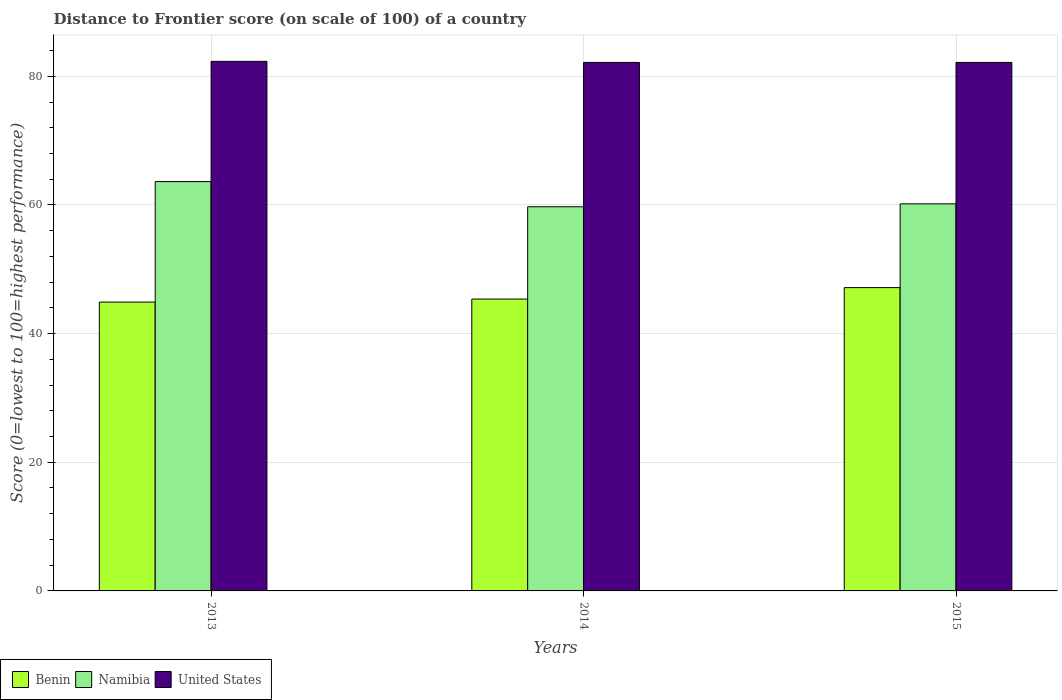How many different coloured bars are there?
Ensure brevity in your answer.  3. How many bars are there on the 3rd tick from the left?
Your response must be concise. 3. How many bars are there on the 2nd tick from the right?
Offer a terse response. 3. In how many cases, is the number of bars for a given year not equal to the number of legend labels?
Offer a very short reply. 0. What is the distance to frontier score of in United States in 2014?
Your response must be concise. 82.15. Across all years, what is the maximum distance to frontier score of in Benin?
Your response must be concise. 47.15. Across all years, what is the minimum distance to frontier score of in Namibia?
Provide a succinct answer. 59.72. What is the total distance to frontier score of in Benin in the graph?
Offer a terse response. 137.42. What is the difference between the distance to frontier score of in United States in 2014 and that in 2015?
Provide a short and direct response. 0. What is the difference between the distance to frontier score of in Namibia in 2015 and the distance to frontier score of in Benin in 2013?
Make the answer very short. 15.27. What is the average distance to frontier score of in Benin per year?
Offer a very short reply. 45.81. In the year 2013, what is the difference between the distance to frontier score of in United States and distance to frontier score of in Benin?
Offer a very short reply. 37.42. In how many years, is the distance to frontier score of in United States greater than 56?
Provide a succinct answer. 3. What is the ratio of the distance to frontier score of in Benin in 2013 to that in 2014?
Offer a very short reply. 0.99. Is the distance to frontier score of in Benin in 2013 less than that in 2014?
Offer a terse response. Yes. Is the difference between the distance to frontier score of in United States in 2013 and 2015 greater than the difference between the distance to frontier score of in Benin in 2013 and 2015?
Make the answer very short. Yes. What is the difference between the highest and the second highest distance to frontier score of in Namibia?
Offer a terse response. 3.46. What is the difference between the highest and the lowest distance to frontier score of in United States?
Keep it short and to the point. 0.17. In how many years, is the distance to frontier score of in Benin greater than the average distance to frontier score of in Benin taken over all years?
Provide a short and direct response. 1. What does the 1st bar from the left in 2014 represents?
Offer a terse response. Benin. What does the 3rd bar from the right in 2013 represents?
Ensure brevity in your answer.  Benin. Is it the case that in every year, the sum of the distance to frontier score of in Benin and distance to frontier score of in United States is greater than the distance to frontier score of in Namibia?
Ensure brevity in your answer.  Yes. What is the difference between two consecutive major ticks on the Y-axis?
Provide a short and direct response. 20. Are the values on the major ticks of Y-axis written in scientific E-notation?
Keep it short and to the point. No. Does the graph contain grids?
Give a very brief answer. Yes. Where does the legend appear in the graph?
Offer a very short reply. Bottom left. How are the legend labels stacked?
Keep it short and to the point. Horizontal. What is the title of the graph?
Give a very brief answer. Distance to Frontier score (on scale of 100) of a country. Does "Papua New Guinea" appear as one of the legend labels in the graph?
Offer a terse response. No. What is the label or title of the X-axis?
Provide a succinct answer. Years. What is the label or title of the Y-axis?
Keep it short and to the point. Score (0=lowest to 100=highest performance). What is the Score (0=lowest to 100=highest performance) in Benin in 2013?
Your answer should be compact. 44.9. What is the Score (0=lowest to 100=highest performance) in Namibia in 2013?
Your response must be concise. 63.63. What is the Score (0=lowest to 100=highest performance) of United States in 2013?
Your response must be concise. 82.32. What is the Score (0=lowest to 100=highest performance) of Benin in 2014?
Offer a terse response. 45.37. What is the Score (0=lowest to 100=highest performance) of Namibia in 2014?
Keep it short and to the point. 59.72. What is the Score (0=lowest to 100=highest performance) in United States in 2014?
Your answer should be compact. 82.15. What is the Score (0=lowest to 100=highest performance) in Benin in 2015?
Your answer should be very brief. 47.15. What is the Score (0=lowest to 100=highest performance) of Namibia in 2015?
Offer a terse response. 60.17. What is the Score (0=lowest to 100=highest performance) in United States in 2015?
Keep it short and to the point. 82.15. Across all years, what is the maximum Score (0=lowest to 100=highest performance) in Benin?
Your answer should be compact. 47.15. Across all years, what is the maximum Score (0=lowest to 100=highest performance) of Namibia?
Give a very brief answer. 63.63. Across all years, what is the maximum Score (0=lowest to 100=highest performance) of United States?
Make the answer very short. 82.32. Across all years, what is the minimum Score (0=lowest to 100=highest performance) of Benin?
Provide a short and direct response. 44.9. Across all years, what is the minimum Score (0=lowest to 100=highest performance) of Namibia?
Offer a terse response. 59.72. Across all years, what is the minimum Score (0=lowest to 100=highest performance) of United States?
Your response must be concise. 82.15. What is the total Score (0=lowest to 100=highest performance) of Benin in the graph?
Keep it short and to the point. 137.42. What is the total Score (0=lowest to 100=highest performance) of Namibia in the graph?
Your response must be concise. 183.52. What is the total Score (0=lowest to 100=highest performance) of United States in the graph?
Ensure brevity in your answer.  246.62. What is the difference between the Score (0=lowest to 100=highest performance) in Benin in 2013 and that in 2014?
Provide a short and direct response. -0.47. What is the difference between the Score (0=lowest to 100=highest performance) in Namibia in 2013 and that in 2014?
Provide a short and direct response. 3.91. What is the difference between the Score (0=lowest to 100=highest performance) in United States in 2013 and that in 2014?
Your answer should be compact. 0.17. What is the difference between the Score (0=lowest to 100=highest performance) in Benin in 2013 and that in 2015?
Provide a succinct answer. -2.25. What is the difference between the Score (0=lowest to 100=highest performance) of Namibia in 2013 and that in 2015?
Provide a short and direct response. 3.46. What is the difference between the Score (0=lowest to 100=highest performance) in United States in 2013 and that in 2015?
Your answer should be very brief. 0.17. What is the difference between the Score (0=lowest to 100=highest performance) in Benin in 2014 and that in 2015?
Your answer should be very brief. -1.78. What is the difference between the Score (0=lowest to 100=highest performance) of Namibia in 2014 and that in 2015?
Keep it short and to the point. -0.45. What is the difference between the Score (0=lowest to 100=highest performance) in United States in 2014 and that in 2015?
Your answer should be very brief. 0. What is the difference between the Score (0=lowest to 100=highest performance) of Benin in 2013 and the Score (0=lowest to 100=highest performance) of Namibia in 2014?
Provide a succinct answer. -14.82. What is the difference between the Score (0=lowest to 100=highest performance) of Benin in 2013 and the Score (0=lowest to 100=highest performance) of United States in 2014?
Offer a very short reply. -37.25. What is the difference between the Score (0=lowest to 100=highest performance) in Namibia in 2013 and the Score (0=lowest to 100=highest performance) in United States in 2014?
Make the answer very short. -18.52. What is the difference between the Score (0=lowest to 100=highest performance) in Benin in 2013 and the Score (0=lowest to 100=highest performance) in Namibia in 2015?
Your response must be concise. -15.27. What is the difference between the Score (0=lowest to 100=highest performance) in Benin in 2013 and the Score (0=lowest to 100=highest performance) in United States in 2015?
Offer a very short reply. -37.25. What is the difference between the Score (0=lowest to 100=highest performance) of Namibia in 2013 and the Score (0=lowest to 100=highest performance) of United States in 2015?
Ensure brevity in your answer.  -18.52. What is the difference between the Score (0=lowest to 100=highest performance) in Benin in 2014 and the Score (0=lowest to 100=highest performance) in Namibia in 2015?
Keep it short and to the point. -14.8. What is the difference between the Score (0=lowest to 100=highest performance) of Benin in 2014 and the Score (0=lowest to 100=highest performance) of United States in 2015?
Your answer should be very brief. -36.78. What is the difference between the Score (0=lowest to 100=highest performance) in Namibia in 2014 and the Score (0=lowest to 100=highest performance) in United States in 2015?
Make the answer very short. -22.43. What is the average Score (0=lowest to 100=highest performance) of Benin per year?
Keep it short and to the point. 45.81. What is the average Score (0=lowest to 100=highest performance) in Namibia per year?
Offer a very short reply. 61.17. What is the average Score (0=lowest to 100=highest performance) of United States per year?
Give a very brief answer. 82.21. In the year 2013, what is the difference between the Score (0=lowest to 100=highest performance) of Benin and Score (0=lowest to 100=highest performance) of Namibia?
Make the answer very short. -18.73. In the year 2013, what is the difference between the Score (0=lowest to 100=highest performance) in Benin and Score (0=lowest to 100=highest performance) in United States?
Provide a short and direct response. -37.42. In the year 2013, what is the difference between the Score (0=lowest to 100=highest performance) in Namibia and Score (0=lowest to 100=highest performance) in United States?
Make the answer very short. -18.69. In the year 2014, what is the difference between the Score (0=lowest to 100=highest performance) in Benin and Score (0=lowest to 100=highest performance) in Namibia?
Provide a succinct answer. -14.35. In the year 2014, what is the difference between the Score (0=lowest to 100=highest performance) in Benin and Score (0=lowest to 100=highest performance) in United States?
Keep it short and to the point. -36.78. In the year 2014, what is the difference between the Score (0=lowest to 100=highest performance) of Namibia and Score (0=lowest to 100=highest performance) of United States?
Give a very brief answer. -22.43. In the year 2015, what is the difference between the Score (0=lowest to 100=highest performance) in Benin and Score (0=lowest to 100=highest performance) in Namibia?
Your answer should be very brief. -13.02. In the year 2015, what is the difference between the Score (0=lowest to 100=highest performance) in Benin and Score (0=lowest to 100=highest performance) in United States?
Offer a very short reply. -35. In the year 2015, what is the difference between the Score (0=lowest to 100=highest performance) in Namibia and Score (0=lowest to 100=highest performance) in United States?
Offer a very short reply. -21.98. What is the ratio of the Score (0=lowest to 100=highest performance) of Namibia in 2013 to that in 2014?
Offer a terse response. 1.07. What is the ratio of the Score (0=lowest to 100=highest performance) in United States in 2013 to that in 2014?
Provide a succinct answer. 1. What is the ratio of the Score (0=lowest to 100=highest performance) in Benin in 2013 to that in 2015?
Provide a succinct answer. 0.95. What is the ratio of the Score (0=lowest to 100=highest performance) of Namibia in 2013 to that in 2015?
Offer a very short reply. 1.06. What is the ratio of the Score (0=lowest to 100=highest performance) in Benin in 2014 to that in 2015?
Offer a terse response. 0.96. What is the ratio of the Score (0=lowest to 100=highest performance) of Namibia in 2014 to that in 2015?
Offer a very short reply. 0.99. What is the ratio of the Score (0=lowest to 100=highest performance) in United States in 2014 to that in 2015?
Your answer should be compact. 1. What is the difference between the highest and the second highest Score (0=lowest to 100=highest performance) in Benin?
Keep it short and to the point. 1.78. What is the difference between the highest and the second highest Score (0=lowest to 100=highest performance) of Namibia?
Keep it short and to the point. 3.46. What is the difference between the highest and the second highest Score (0=lowest to 100=highest performance) in United States?
Offer a terse response. 0.17. What is the difference between the highest and the lowest Score (0=lowest to 100=highest performance) in Benin?
Ensure brevity in your answer.  2.25. What is the difference between the highest and the lowest Score (0=lowest to 100=highest performance) of Namibia?
Provide a short and direct response. 3.91. What is the difference between the highest and the lowest Score (0=lowest to 100=highest performance) in United States?
Your response must be concise. 0.17. 